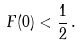<formula> <loc_0><loc_0><loc_500><loc_500>F ( 0 ) < \frac { 1 } { 2 } \, .</formula> 